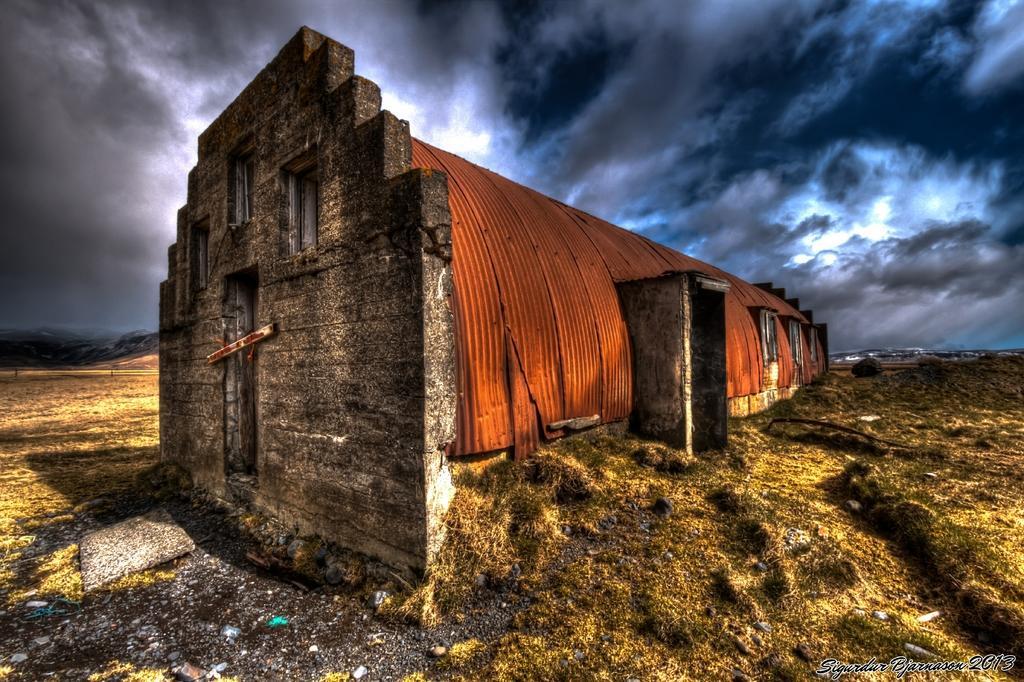In one or two sentences, can you explain what this image depicts? In this image I can see the building which is in brown and grey color. And I can see the windows to it. It is on the ground. In the back I can see many clouds and the sky. 